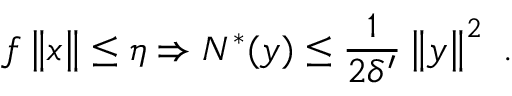Convert formula to latex. <formula><loc_0><loc_0><loc_500><loc_500>f \left \| x \right \| \leq \eta \Rightarrow N ^ { \ast } ( y ) \leq \frac { 1 } { 2 \delta ^ { \prime } } \left \| y \right \| ^ { 2 } \ .</formula> 